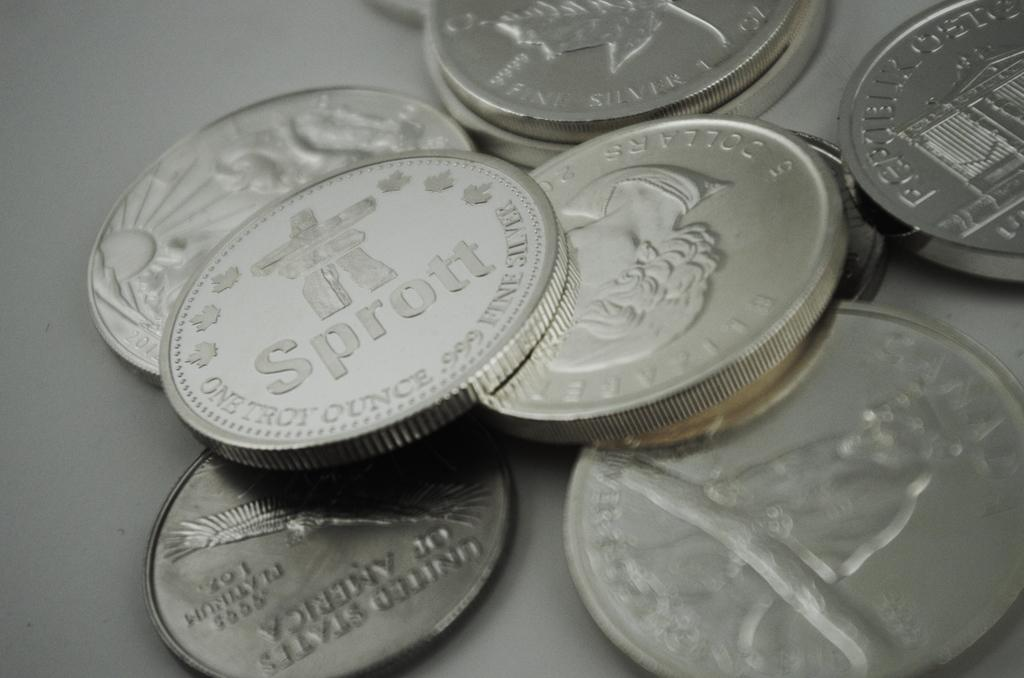<image>
Share a concise interpretation of the image provided. A coin has the word Sprott in the center of it. 